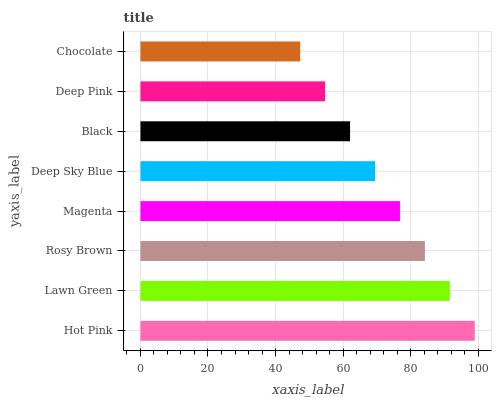Is Chocolate the minimum?
Answer yes or no. Yes. Is Hot Pink the maximum?
Answer yes or no. Yes. Is Lawn Green the minimum?
Answer yes or no. No. Is Lawn Green the maximum?
Answer yes or no. No. Is Hot Pink greater than Lawn Green?
Answer yes or no. Yes. Is Lawn Green less than Hot Pink?
Answer yes or no. Yes. Is Lawn Green greater than Hot Pink?
Answer yes or no. No. Is Hot Pink less than Lawn Green?
Answer yes or no. No. Is Magenta the high median?
Answer yes or no. Yes. Is Deep Sky Blue the low median?
Answer yes or no. Yes. Is Chocolate the high median?
Answer yes or no. No. Is Rosy Brown the low median?
Answer yes or no. No. 